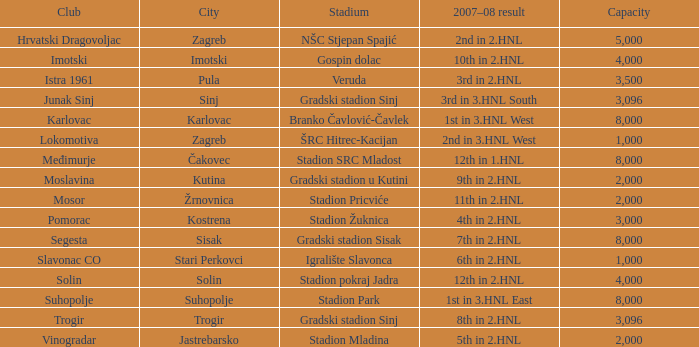What stadium has 9th in 2.hnl as the 2007-08 result? Gradski stadion u Kutini. 